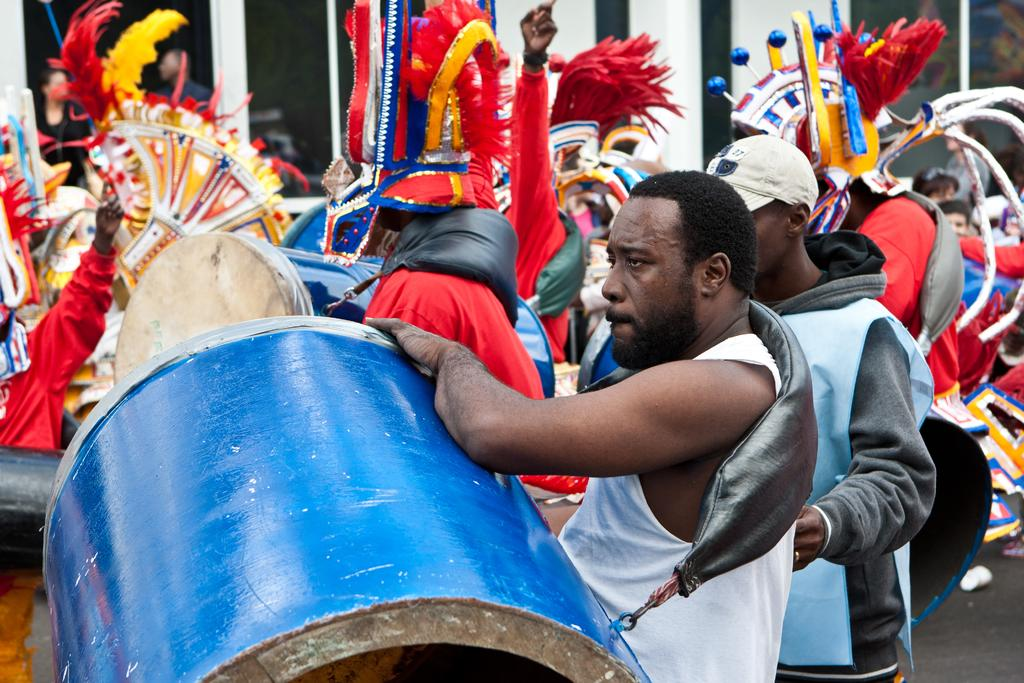Where was the image taken? The image was clicked outside. How many people are present in the image? There are many people in the image. What can be observed about the attire of the people in the image? The people are wearing different kinds of dress. What activity are some of the people engaged in? Some people are playing drums in the image. What type of scent can be smelled in the image? There is no information about any scent in the image, as it only provides visual details. 